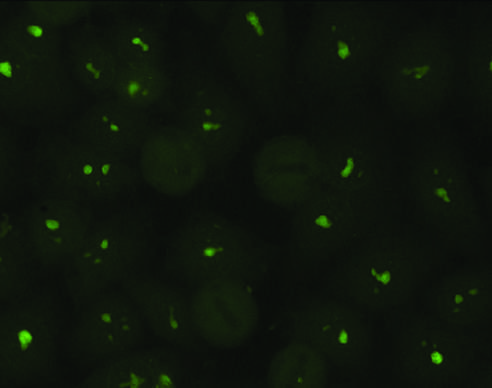s atrophy of the brain typical of antibodies against nucleolar proteins?
Answer the question using a single word or phrase. No 